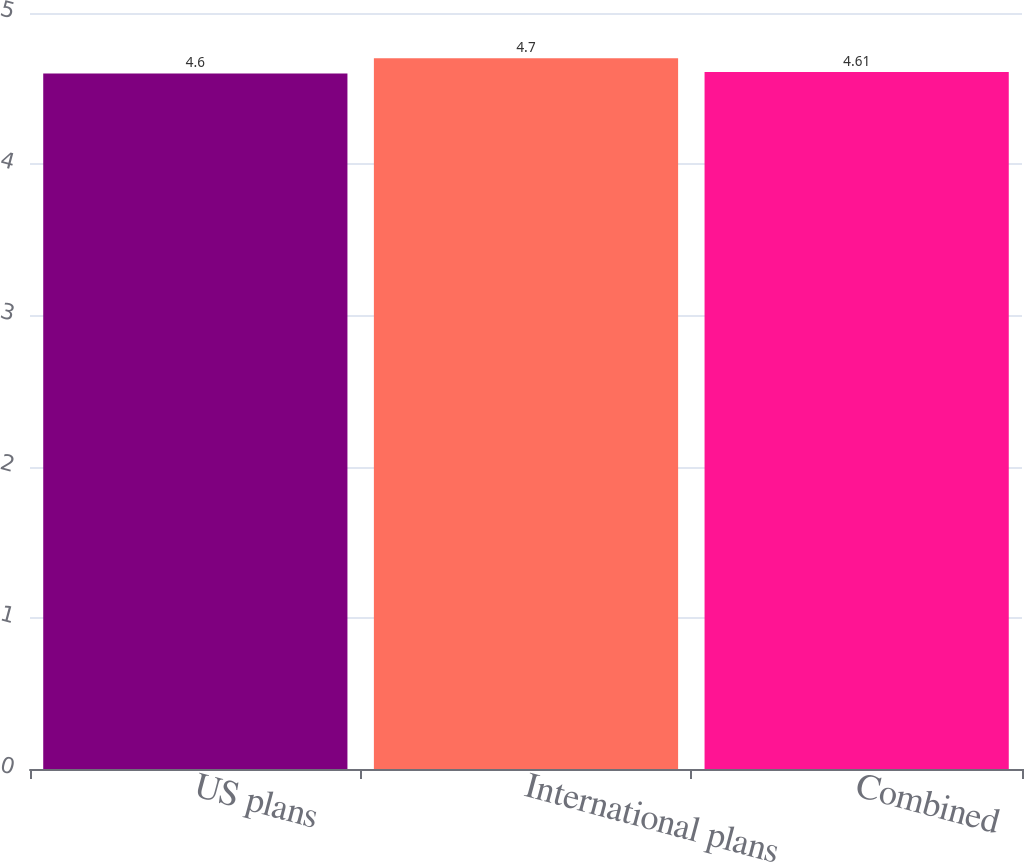Convert chart to OTSL. <chart><loc_0><loc_0><loc_500><loc_500><bar_chart><fcel>US plans<fcel>International plans<fcel>Combined<nl><fcel>4.6<fcel>4.7<fcel>4.61<nl></chart> 